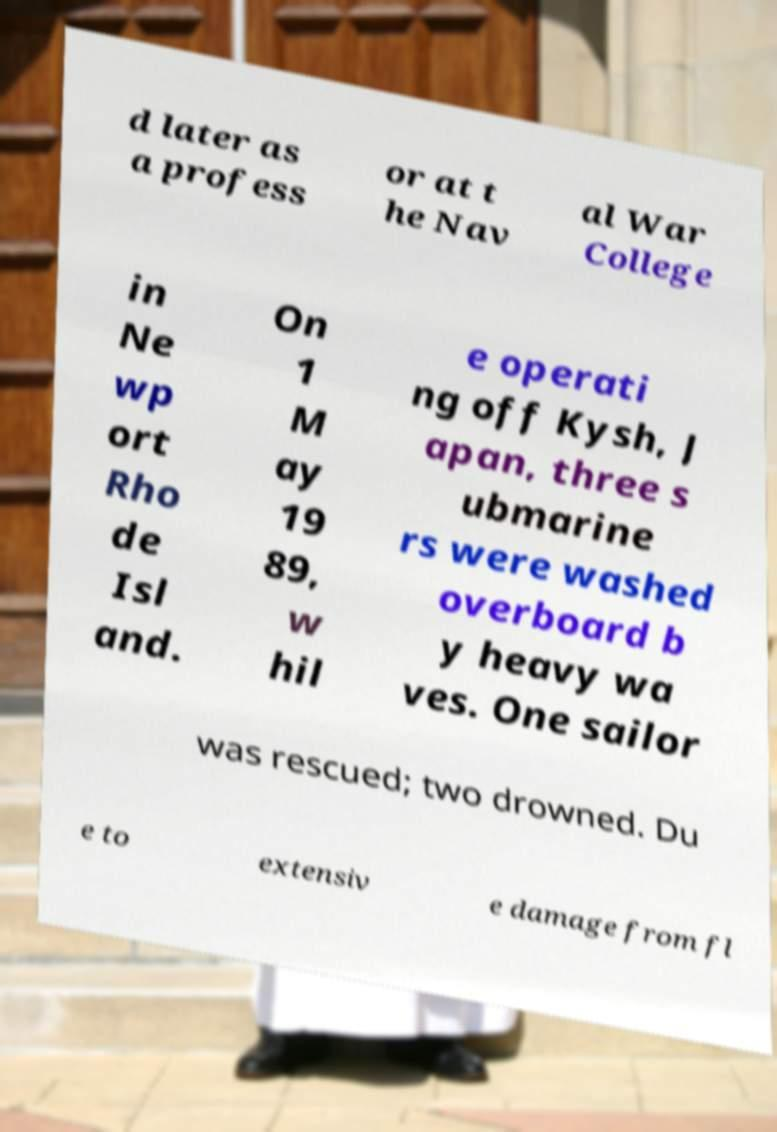For documentation purposes, I need the text within this image transcribed. Could you provide that? d later as a profess or at t he Nav al War College in Ne wp ort Rho de Isl and. On 1 M ay 19 89, w hil e operati ng off Kysh, J apan, three s ubmarine rs were washed overboard b y heavy wa ves. One sailor was rescued; two drowned. Du e to extensiv e damage from fl 